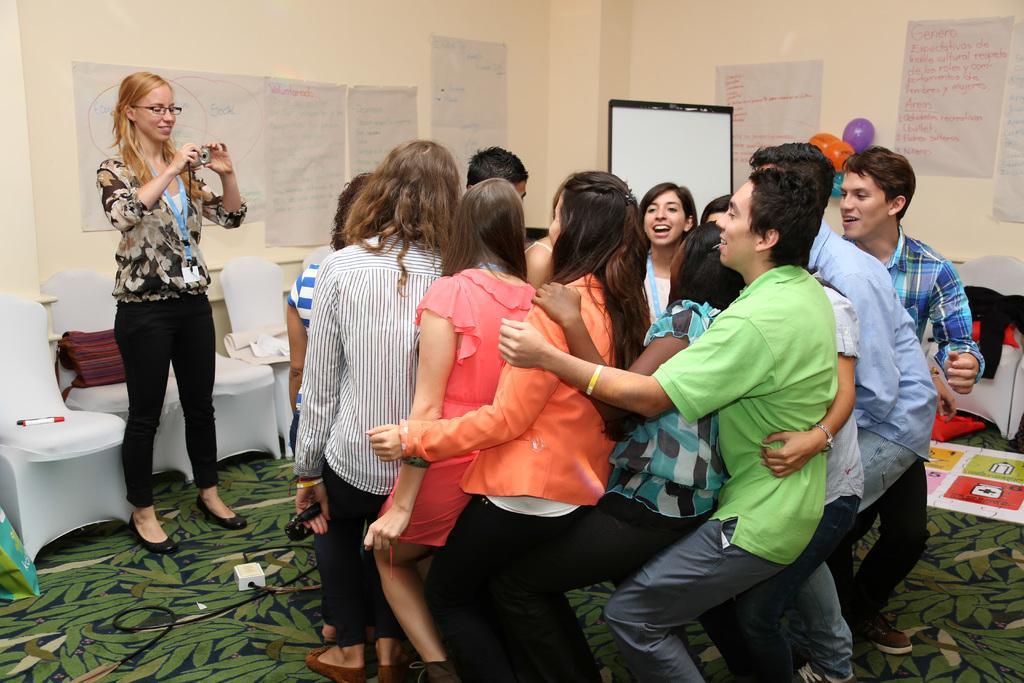Could you give a brief overview of what you see in this image? On the left side, there is a woman smiling, holding a camera and standing. Beside her, there are white color chairs, on which there are some objects. In front of her, there are other persons on the floor. In the background, there are posters pasted on the wall and there is a screen. 